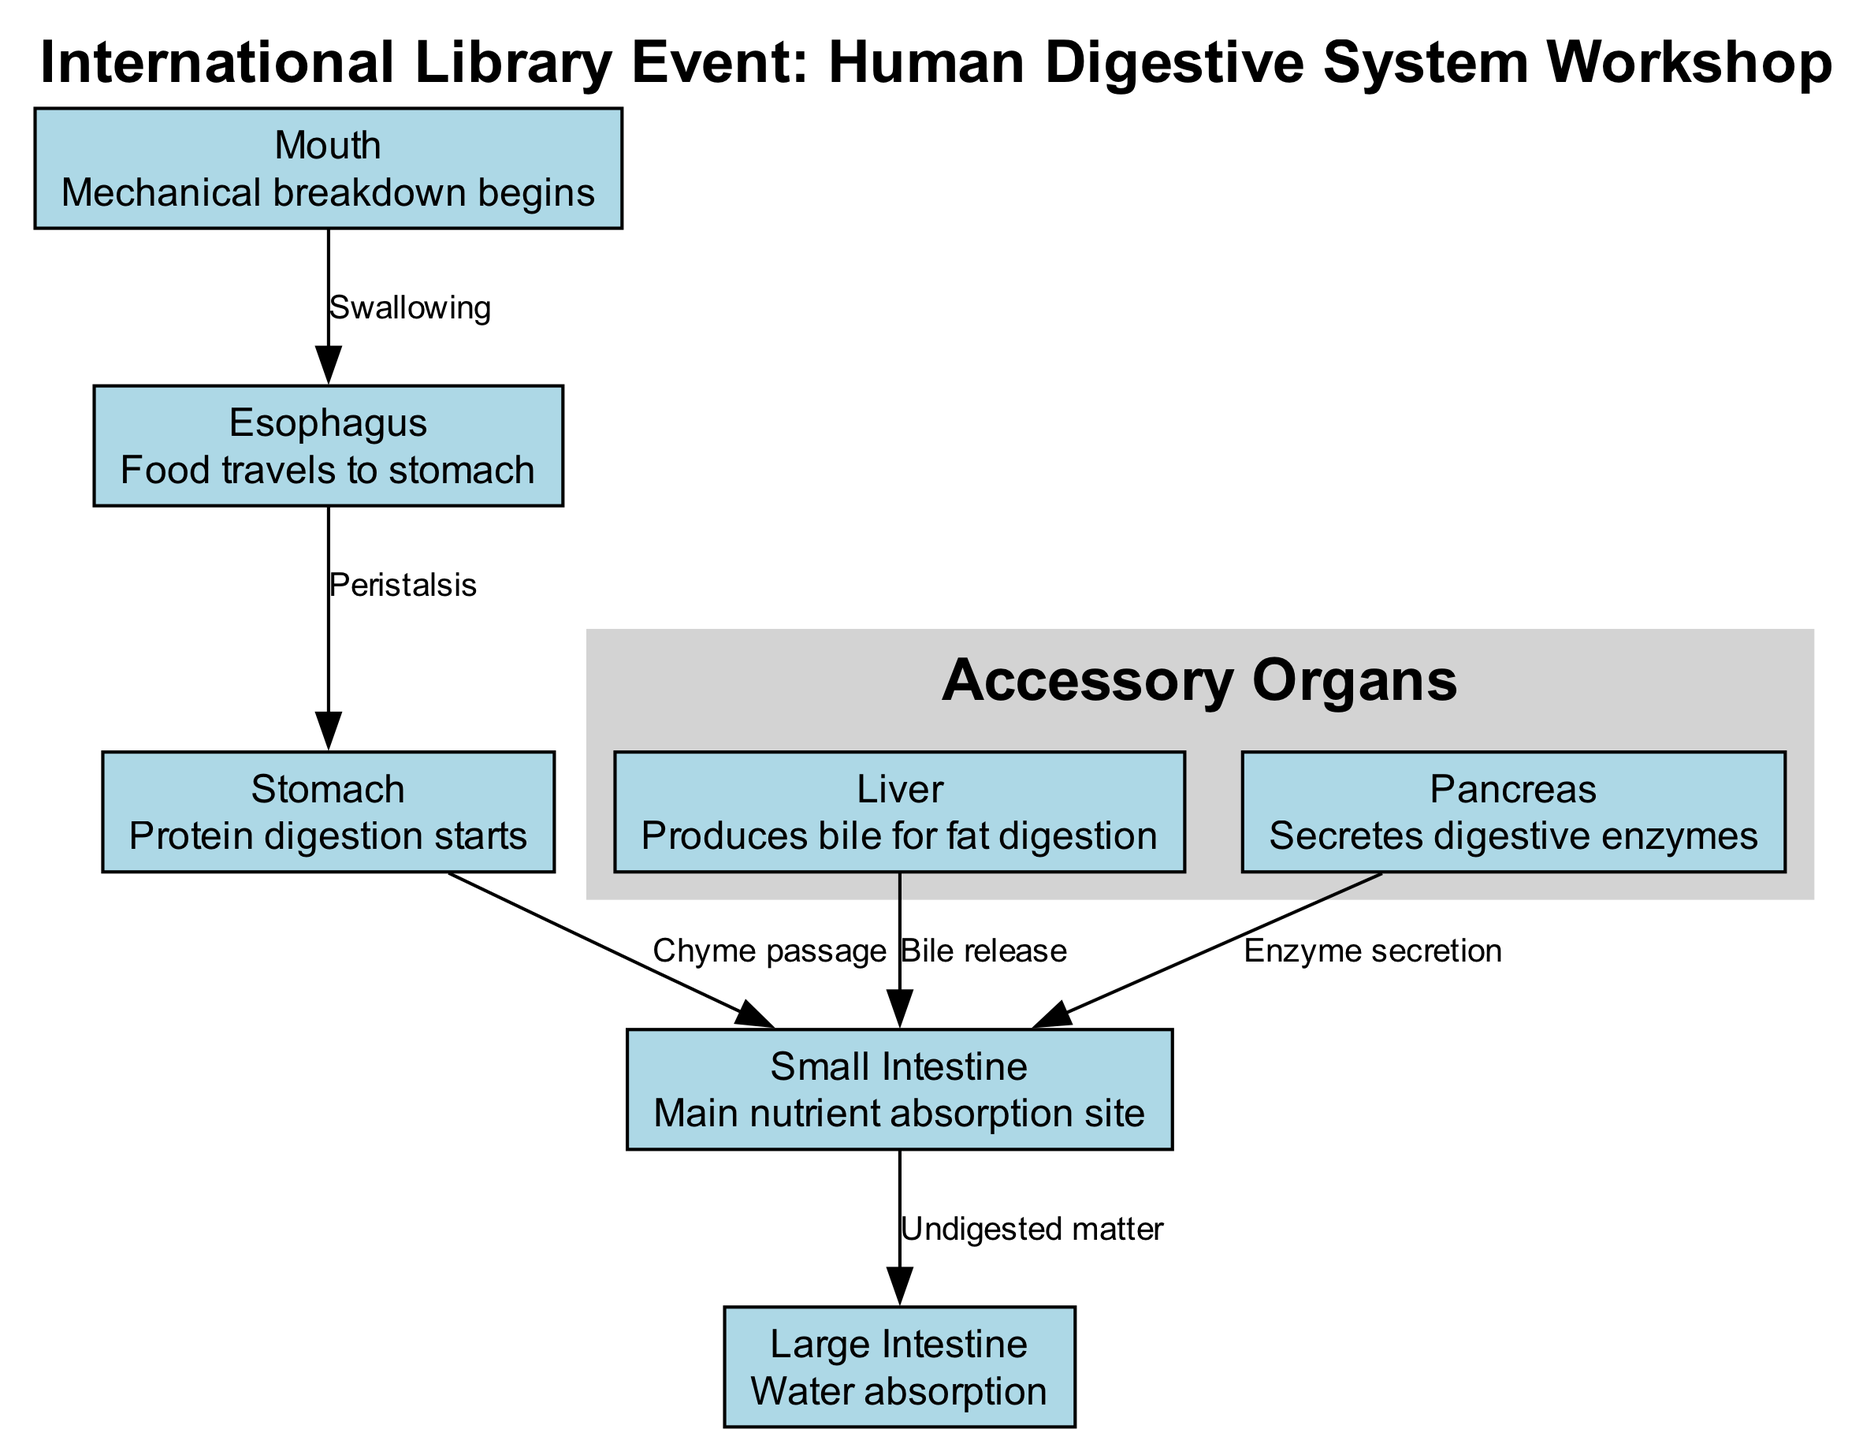What is the main nutrient absorption site? The diagram indicates that the "Small Intestine" is labeled as the "Main nutrient absorption site." Therefore, by directly referencing this information, we can identify the answer.
Answer: Small Intestine How many total organs are represented in the diagram? By counting the number of nodes that are listed, namely: Mouth, Esophagus, Stomach, Small Intestine, Large Intestine, Liver, and Pancreas; we find there are 7 organs shown in the diagram.
Answer: 7 What travels from the esophagus to the stomach? The edge connecting the Esophagus to the Stomach is labeled "Peristalsis," which is defined as the process that moves food downward from the esophagus to the stomach. Thus, the answer is derived from this label.
Answer: Peristalsis What is the role of the liver in the digestive process? The diagram specifies that the Liver "Produces bile for fat digestion," indicating its function in the process. Hence, this information leads us to the conclusion regarding the role of the liver.
Answer: Produces bile for fat digestion What happens to undigested matter after the small intestine? According to the diagram, undigested matter moves from the "Small Intestine" to the "Large Intestine." The label on this edge clearly indicates this connection and the nature of the matter being discussed.
Answer: Moves to the Large Intestine How is chyme passed to the small intestine? The label on the edge connecting the Stomach to the Small Intestine indicates that this passage is referred to as "Chyme passage." Therefore, the terminology used directly indicates how chyme moves along in the digestive process.
Answer: Chyme passage What digestive enzymes are secreted by the pancreas? The diagram outlines that the "Pancreas" "Secretes digestive enzymes." This information allows us to understand the function of the pancreas in relation to enzyme production in digestion.
Answer: Secretes digestive enzymes Where does bile release occur? Referring to the edge that connects the Liver to the Small Intestine, the label "Bile release" explicitly indicates where this occurs, specifically in the context of the digestive system.
Answer: Small Intestine 